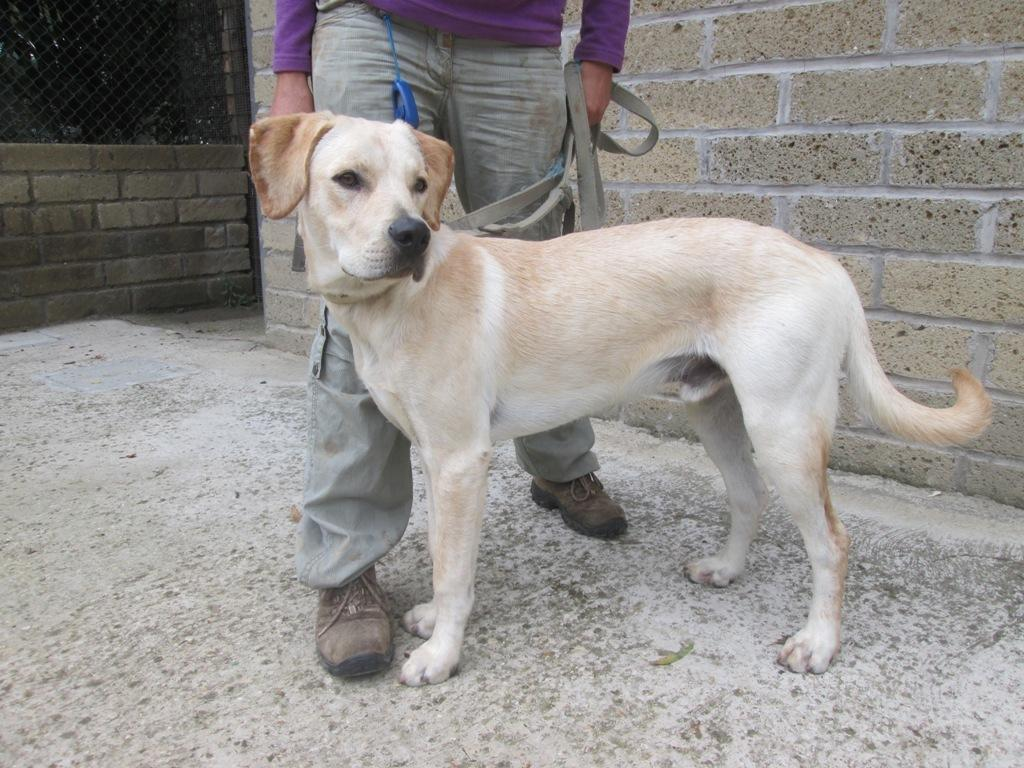What animal is present in the image? There is a dog in the image. What is the color of the dog? The dog is white in color. What is at the bottom of the image? There is a floor at the bottom of the image. Who is standing behind the dog? There is a man standing behind the dog. What can be seen in the background of the image? There is a wall in the background of the image. What type of meat is the dog eating in the image? There is no meat present in the image, and the dog is not eating anything. 